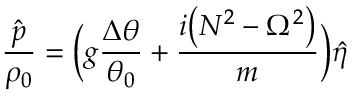Convert formula to latex. <formula><loc_0><loc_0><loc_500><loc_500>\frac { \hat { p } } { \rho _ { 0 } } = \left ( g \frac { \Delta \theta } { \theta _ { 0 } } + \frac { i \left ( N ^ { 2 } - \Omega ^ { 2 } \right ) } { m } \right ) \hat { \eta }</formula> 